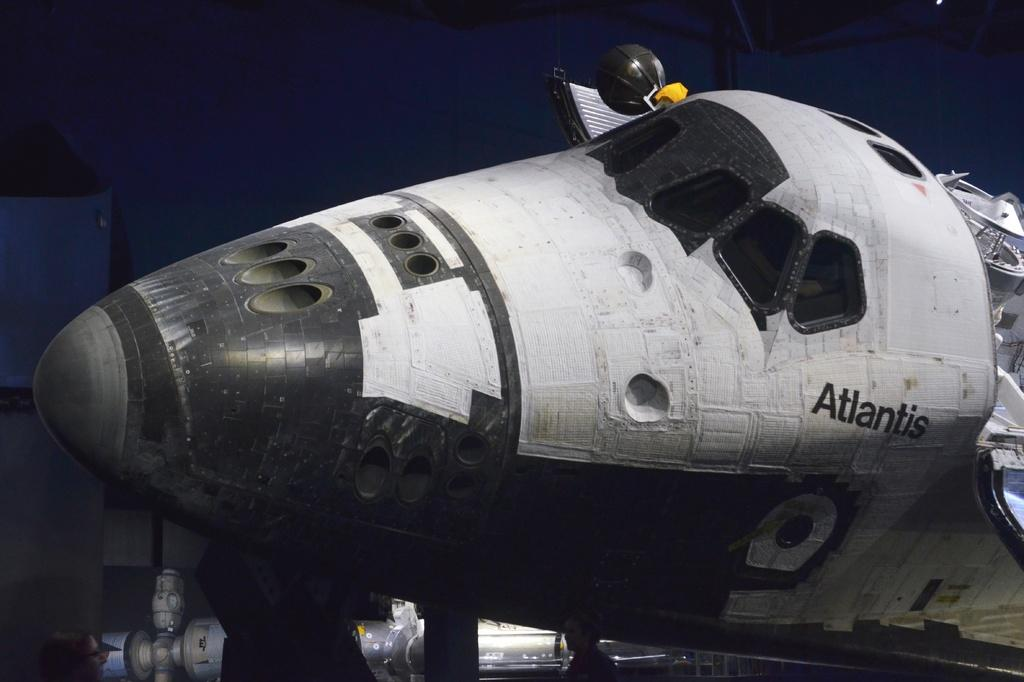What is the main subject of the image? The main subject of the image is an aircraft. What degree does the aircraft have in the image? Aircrafts do not have degrees, as they are machines and not people. The question is not applicable to the image. 